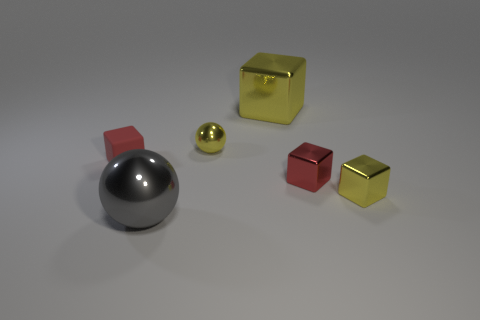Subtract all cyan balls. How many yellow cubes are left? 2 Subtract all large yellow blocks. How many blocks are left? 3 Add 1 yellow objects. How many objects exist? 7 Subtract all gray cubes. Subtract all gray balls. How many cubes are left? 4 Subtract all balls. How many objects are left? 4 Add 5 tiny red cubes. How many tiny red cubes exist? 7 Subtract 1 yellow spheres. How many objects are left? 5 Subtract all large red shiny balls. Subtract all tiny red cubes. How many objects are left? 4 Add 6 yellow metallic balls. How many yellow metallic balls are left? 7 